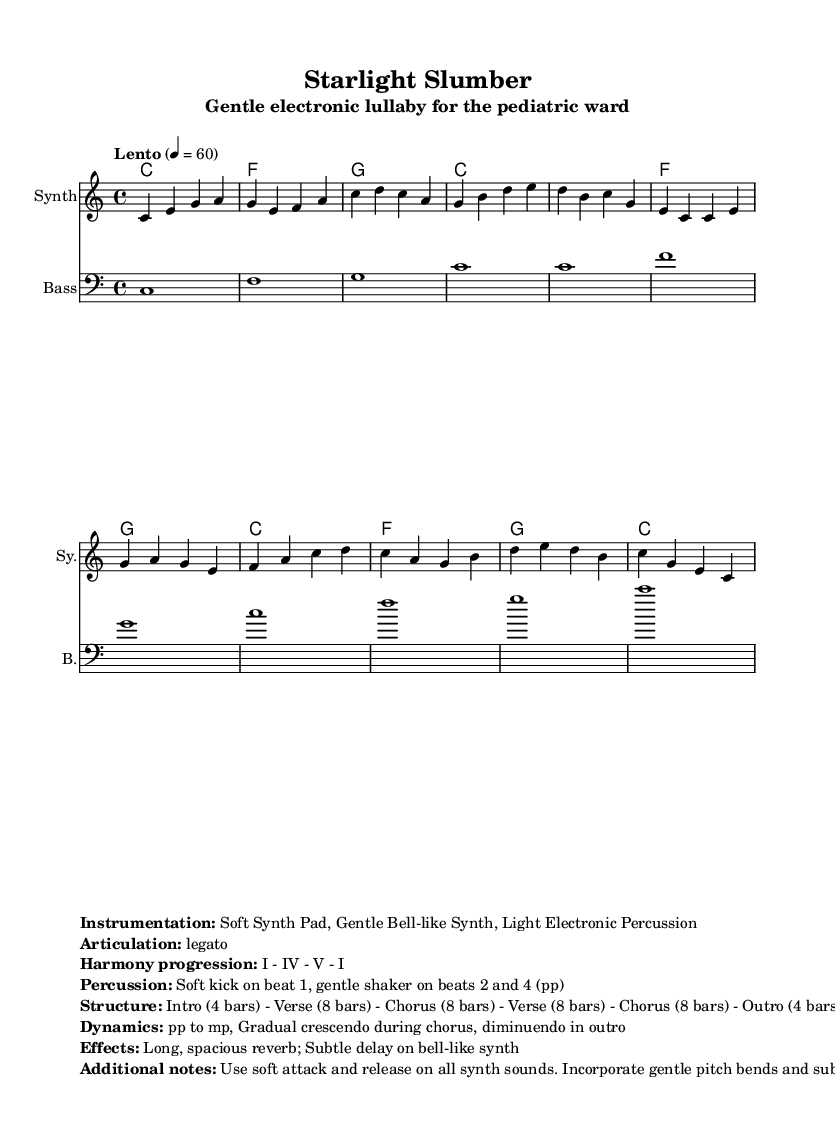What is the key signature of this music? The key signature is C major, which has no sharps or flats.
Answer: C major What is the time signature of this music? The time signature is located at the beginning of the score, indicating that each measure contains four beats, as represented by the 4/4 notation.
Answer: 4/4 What is the tempo marking for this piece? The tempo marking "Lento" is followed by a metronomic indication of 60 beats per minute, which points to a slow pace for the music.
Answer: Lento (60) What is the structure of the piece? The structure can be pieced together by examining the markup section, which clearly outlines an Intro, two Verses, two Choruses, and an Outro. This gives a total of 34 measures, with specifics on each segment presented.
Answer: Intro - Verse - Chorus - Verse - Chorus - Outro How many bars are in the Verse section? By analyzing the score and the descriptive structure notes, each Verse is specified to consist of 8 bars, and there are two such sections in the piece.
Answer: 8 bars What type of synth sounds are used in this composition? The instrumentation section in the markup identifies three main types of synth sounds: a Soft Synth Pad, a Gentle Bell-like Synth, and Light Electronic Percussion.
Answer: Soft Synth Pad, Gentle Bell-like Synth, Light Electronic Percussion What is the dynamics indication for the outro? The dynamics for the outro are described as diminuendo, indicating a gradual decrease in volume, as noted in the dynamics section.
Answer: Diminuendo 